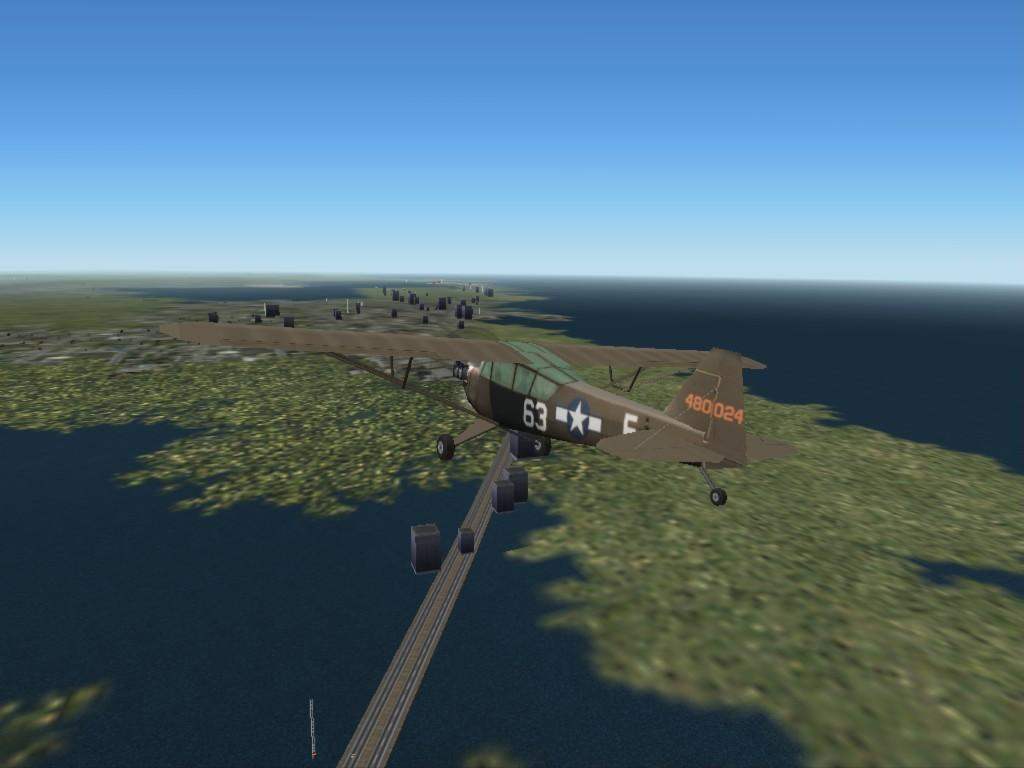<image>
Present a compact description of the photo's key features. A brown plane with 63 in white letters flies in the air. 